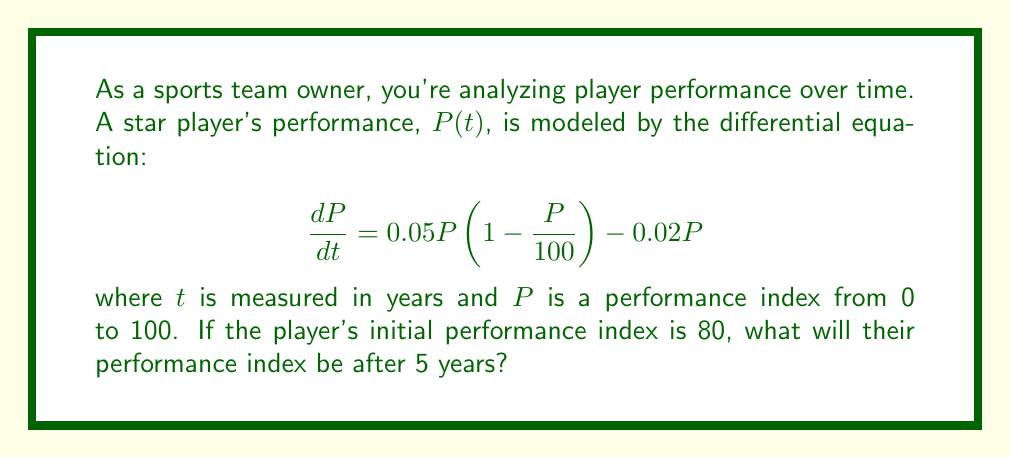Can you answer this question? To solve this problem, we need to use the given first-order differential equation and initial condition:

1) First, let's rearrange the differential equation:
   $$\frac{dP}{dt} = 0.05P - 0.0005P^2 - 0.02P = 0.03P - 0.0005P^2$$

2) This is a separable differential equation. We can rewrite it as:
   $$\frac{dP}{0.03P - 0.0005P^2} = dt$$

3) Integrate both sides:
   $$\int \frac{dP}{0.03P - 0.0005P^2} = \int dt$$

4) The left side can be integrated using partial fractions:
   $$-\frac{1}{0.03} \ln|0.03 - 0.0005P| = t + C$$

5) Using the initial condition $P(0) = 80$, we can find $C$:
   $$-\frac{1}{0.03} \ln|0.03 - 0.0005(80)| = 0 + C$$
   $$C = -\frac{1}{0.03} \ln(0.01) \approx 153.15$$

6) Now we have the general solution:
   $$-\frac{1}{0.03} \ln|0.03 - 0.0005P| = t + 153.15$$

7) To find $P$ after 5 years, we substitute $t = 5$:
   $$-\frac{1}{0.03} \ln|0.03 - 0.0005P| = 5 + 153.15 = 158.15$$

8) Solving for $P$:
   $$\ln|0.03 - 0.0005P| = -0.03(158.15) = -4.7445$$
   $$0.03 - 0.0005P = e^{-4.7445} \approx 0.00869$$
   $$P = \frac{0.03 - 0.00869}{0.0005} \approx 42.62$$

Therefore, after 5 years, the player's performance index will be approximately 42.62.
Answer: After 5 years, the player's performance index will be approximately 42.62. 